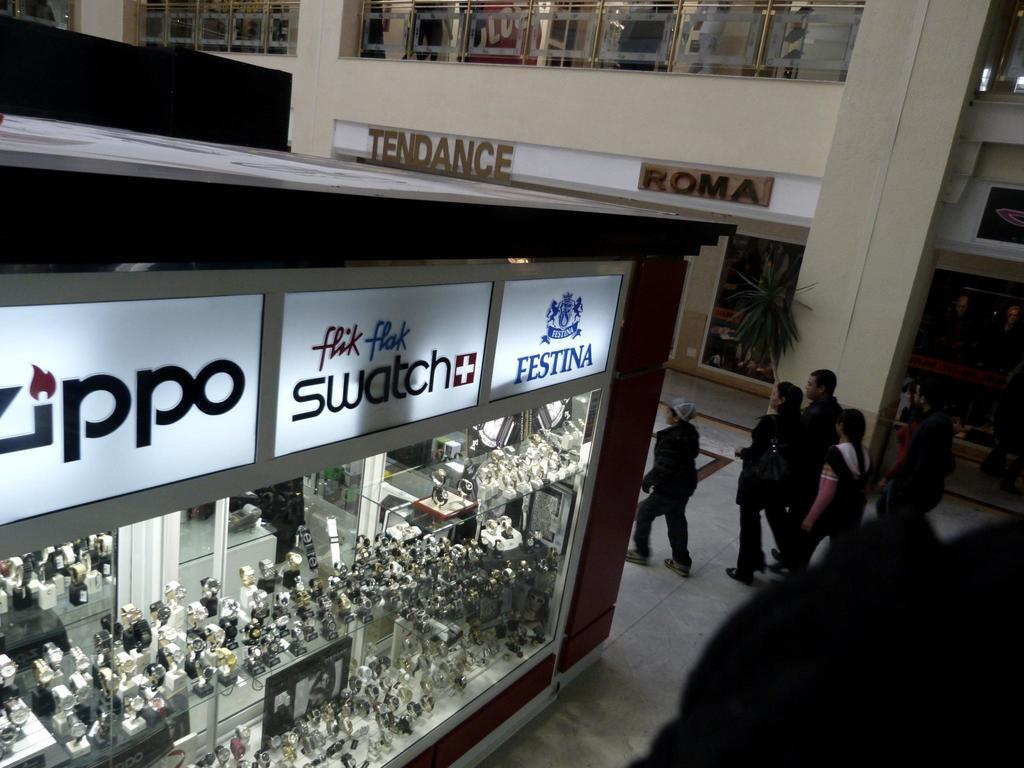What type of establishment is depicted in the image? There is a shop in the image. What items can be found in the shop? The shop contains many watches. What is happening on the right side of the image? There are people walking on the right side of the image. What can be seen in the background of the image? There is a building in the background of the image. How does the digestion process of the people walking on the right side of the image affect the shop's sales? There is no information about the digestion process of the people walking on the right side of the image, nor is there any indication of how it might affect the shop's sales. 